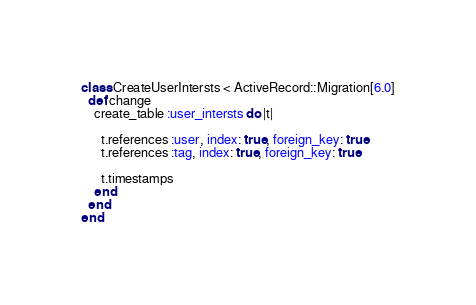<code> <loc_0><loc_0><loc_500><loc_500><_Ruby_>class CreateUserIntersts < ActiveRecord::Migration[6.0]
  def change
    create_table :user_intersts do |t|

      t.references :user, index: true, foreign_key: true
      t.references :tag, index: true, foreign_key: true

      t.timestamps
    end
  end
end
</code> 